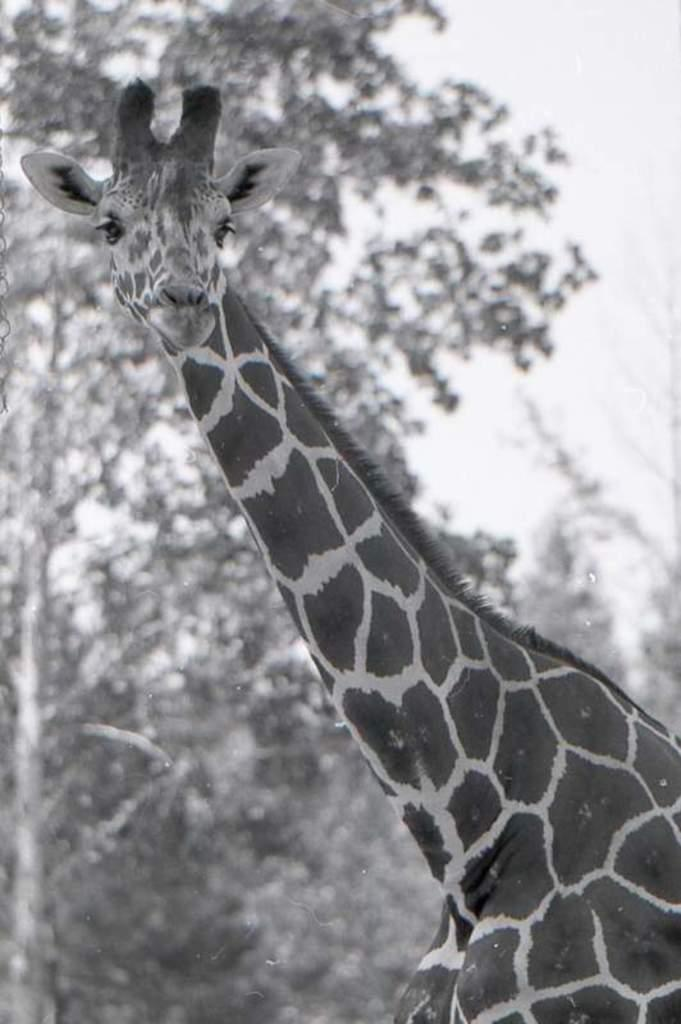What is the color scheme of the image? The image is black and white. What animal is in the front of the image? There is a giraffe in the front of the image. How would you describe the background of the image? The background of the image is blurry. What can be seen in the background of the image? There are trees in the background of the image. What story is your dad telling in the image? There is no reference to a dad or a story in the image; it features a black and white image of a giraffe with a blurry background. 